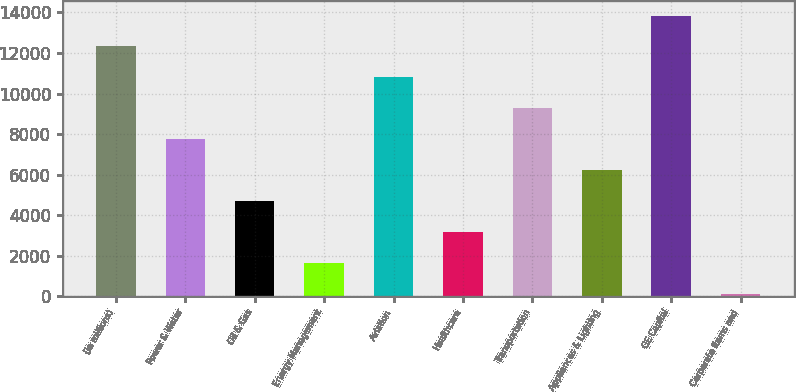<chart> <loc_0><loc_0><loc_500><loc_500><bar_chart><fcel>(In millions)<fcel>Power & Water<fcel>Oil & Gas<fcel>Energy Management<fcel>Aviation<fcel>Healthcare<fcel>Transportation<fcel>Appliances & Lighting<fcel>GE Capital<fcel>Corporate items and<nl><fcel>12319.8<fcel>7737<fcel>4681.8<fcel>1626.6<fcel>10792.2<fcel>3154.2<fcel>9264.6<fcel>6209.4<fcel>13847.4<fcel>99<nl></chart> 